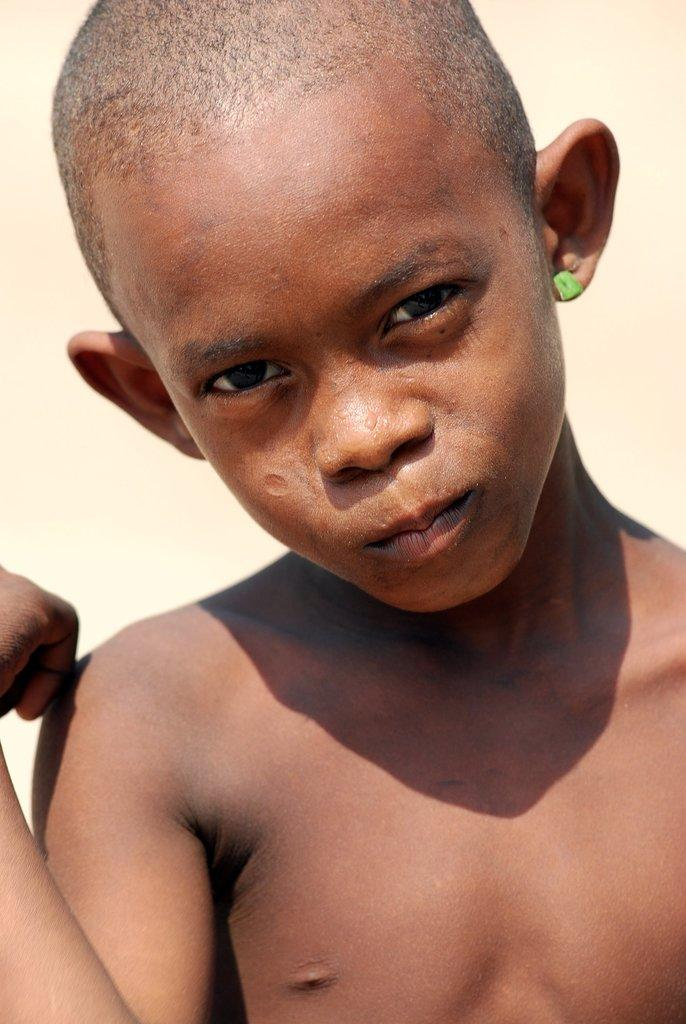What is the main subject of the image? The main subject of the image is an African boy. Can you describe the boy's clothing in the image? The boy is not wearing a shirt in the image. Are there any accessories visible on the boy? Yes, the boy has an earring in his ear. How many ducks are sitting on the jelly tree in the image? There is no jelly tree or ducks present in the image. 